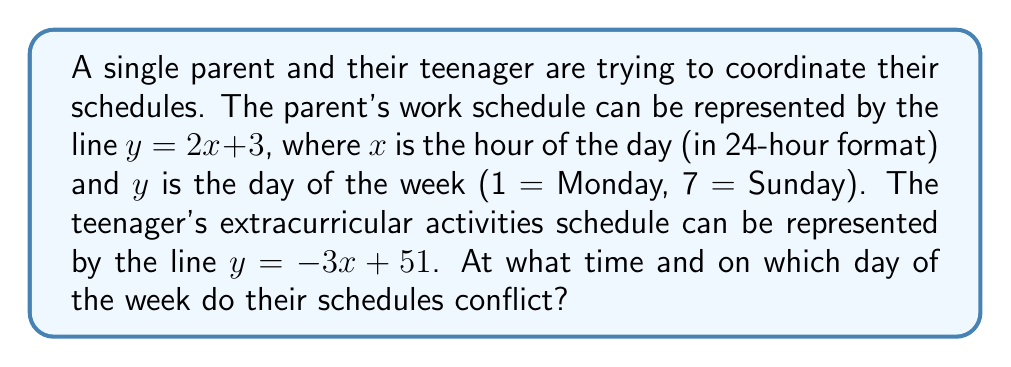Can you solve this math problem? To find the intersection point of these two lines, we need to solve the system of equations:

$$
\begin{cases}
y = 2x + 3 \\
y = -3x + 51
\end{cases}
$$

1) Set the equations equal to each other:
   $2x + 3 = -3x + 51$

2) Add $3x$ to both sides:
   $5x + 3 = 51$

3) Subtract 3 from both sides:
   $5x = 48$

4) Divide both sides by 5:
   $x = 9.6$

5) Substitute this $x$ value into either of the original equations. Let's use $y = 2x + 3$:
   $y = 2(9.6) + 3 = 19.2 + 3 = 22.2$

6) Interpret the results:
   - $x = 9.6$ represents 9:36 AM in 24-hour format
   - $y = 22.2$ represents a day between Tuesday (2) and Wednesday (3), specifically 0.2 days after Tuesday

Therefore, their schedules conflict at 9:36 AM on Tuesday.
Answer: 9:36 AM on Tuesday 